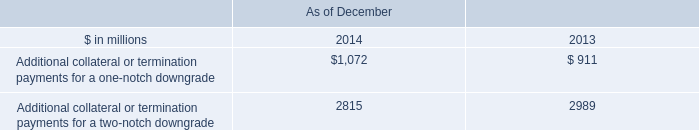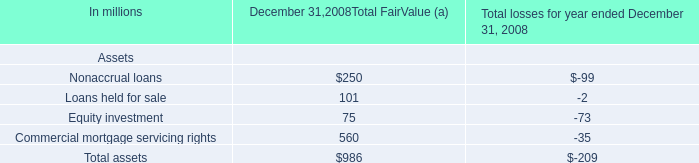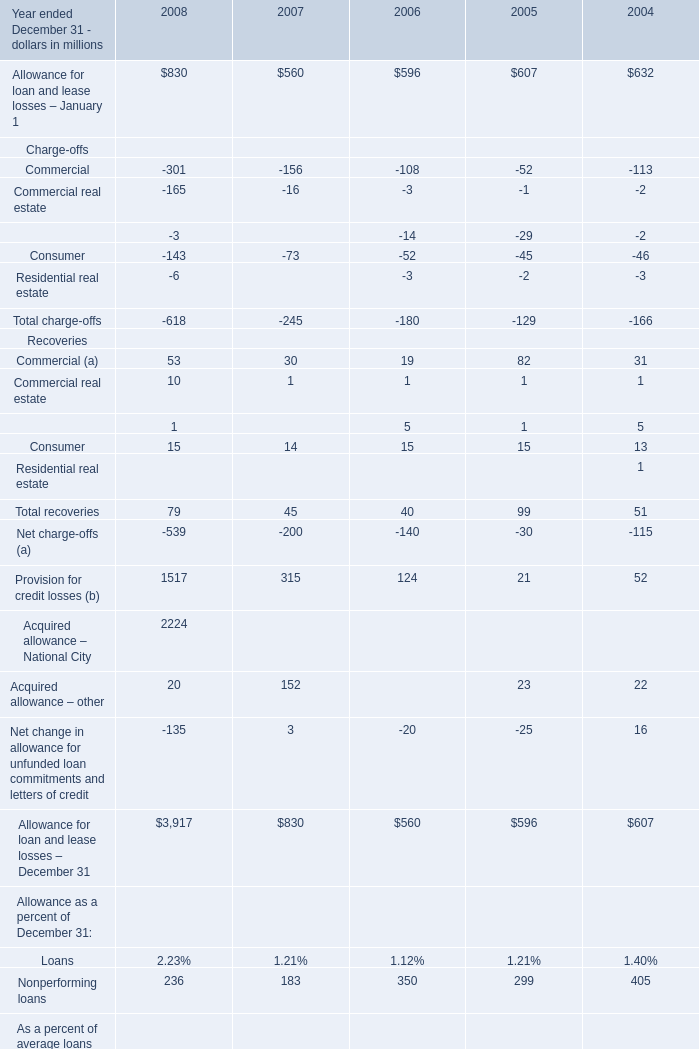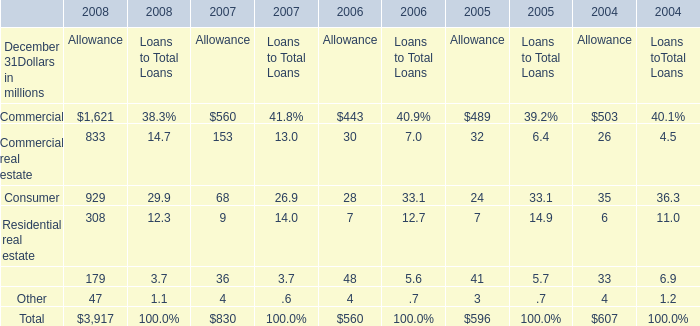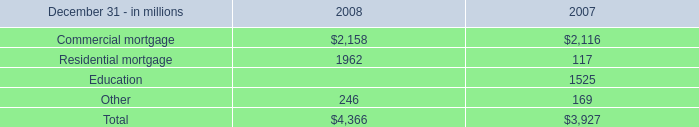What do all Recoveries sum up without those Recoveries smaller than 15, in 2006? (in million) 
Computations: ((1 + 5) + 15)
Answer: 21.0. 